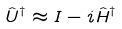<formula> <loc_0><loc_0><loc_500><loc_500>\hat { U } ^ { \dagger } \approx I - i \hat { H } ^ { \dagger }</formula> 